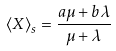<formula> <loc_0><loc_0><loc_500><loc_500>\langle X \rangle _ { s } = \frac { a \mu + b \lambda } { \mu + \lambda }</formula> 